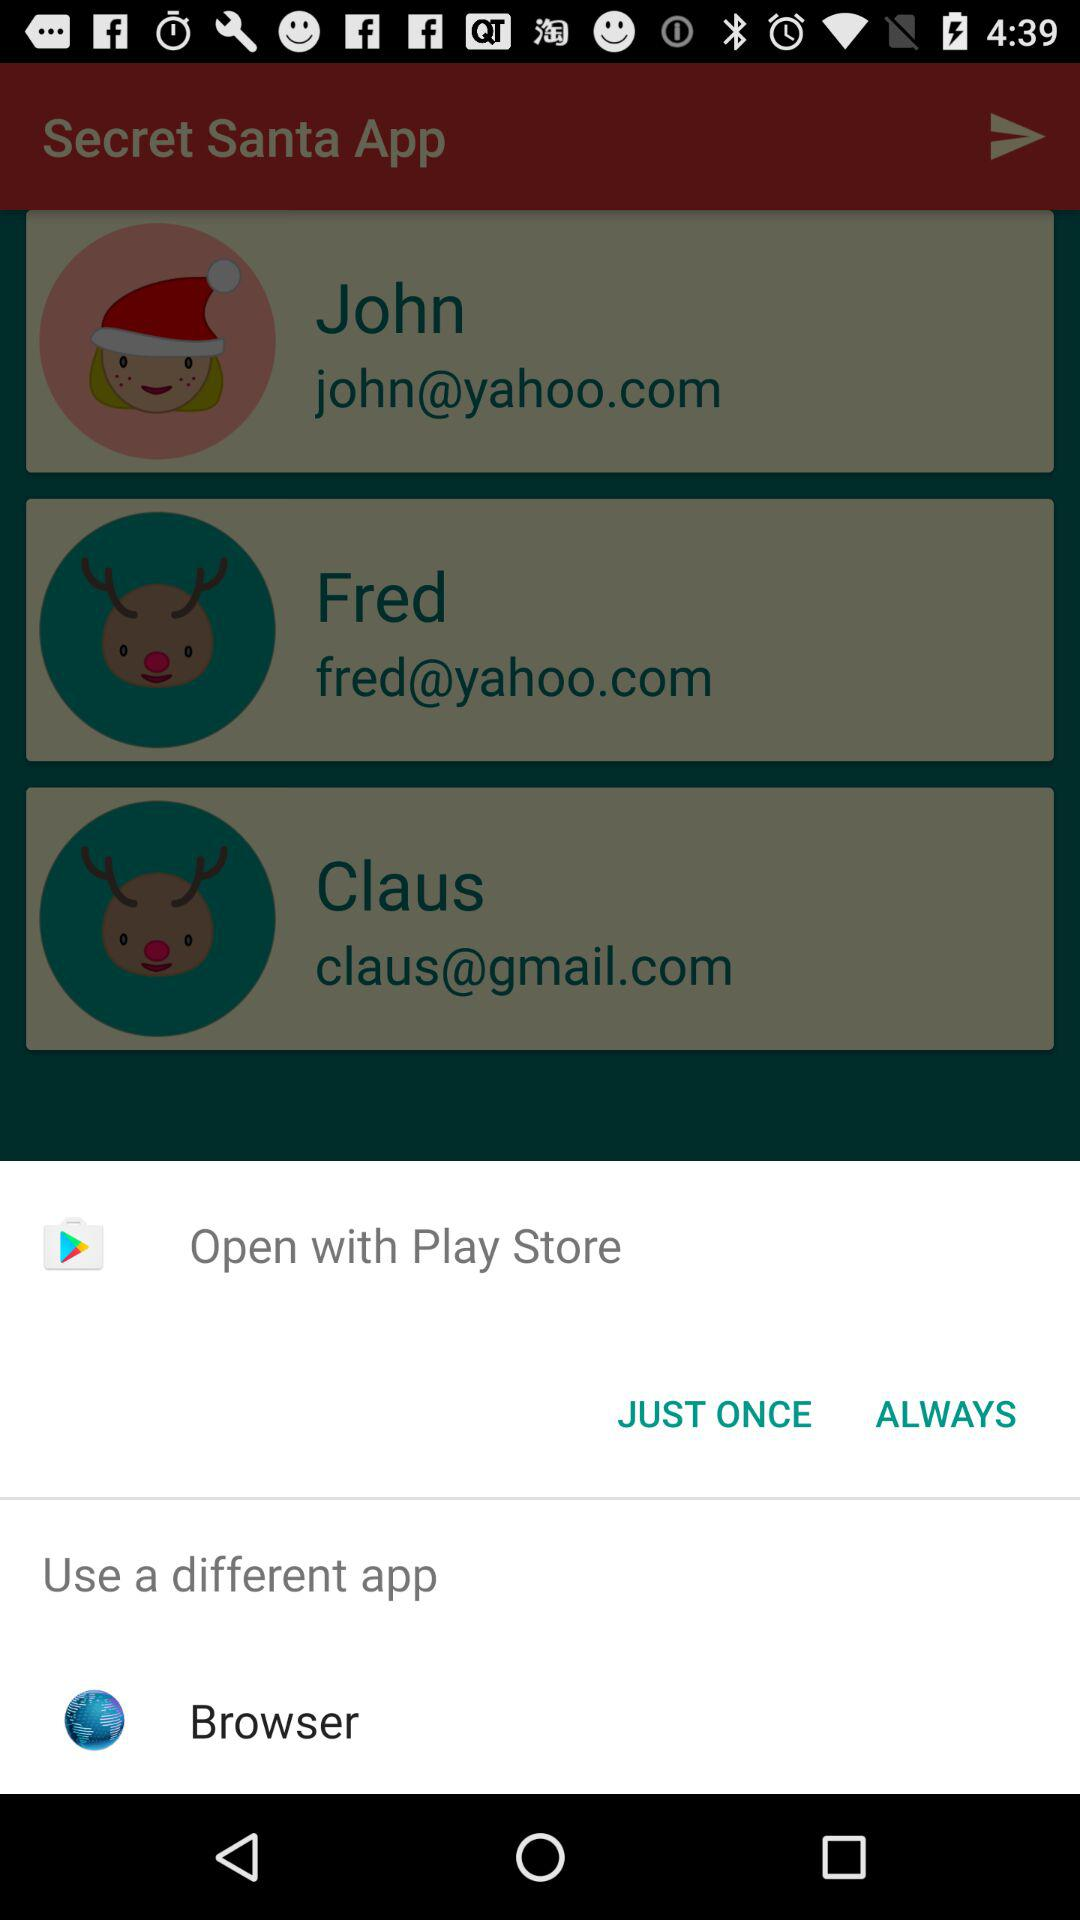What is Rudolph's email address?
When the provided information is insufficient, respond with <no answer>. <no answer> 